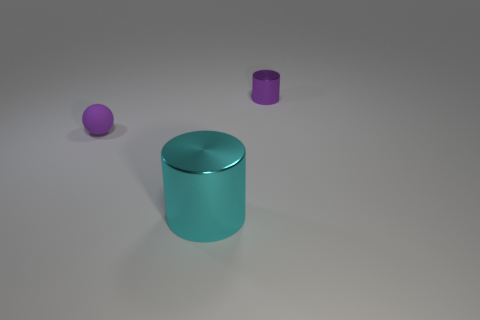What number of small balls are in front of the metallic object that is in front of the metal cylinder that is behind the rubber thing?
Your answer should be compact. 0. Is there any other thing that has the same shape as the tiny purple metallic thing?
Provide a succinct answer. Yes. How many objects are either tiny red metallic blocks or purple rubber things?
Your response must be concise. 1. Does the cyan metallic object have the same shape as the tiny purple object that is to the right of the cyan cylinder?
Keep it short and to the point. Yes. What shape is the big cyan metallic thing that is on the left side of the tiny metallic thing?
Your answer should be very brief. Cylinder. Does the small rubber thing have the same shape as the cyan shiny thing?
Your answer should be compact. No. The purple thing that is the same shape as the big cyan object is what size?
Offer a very short reply. Small. There is a object behind the rubber sphere; does it have the same size as the big cyan thing?
Ensure brevity in your answer.  No. What is the size of the thing that is both to the right of the ball and in front of the small metal cylinder?
Your response must be concise. Large. There is a ball that is the same color as the small metal object; what is it made of?
Make the answer very short. Rubber. 